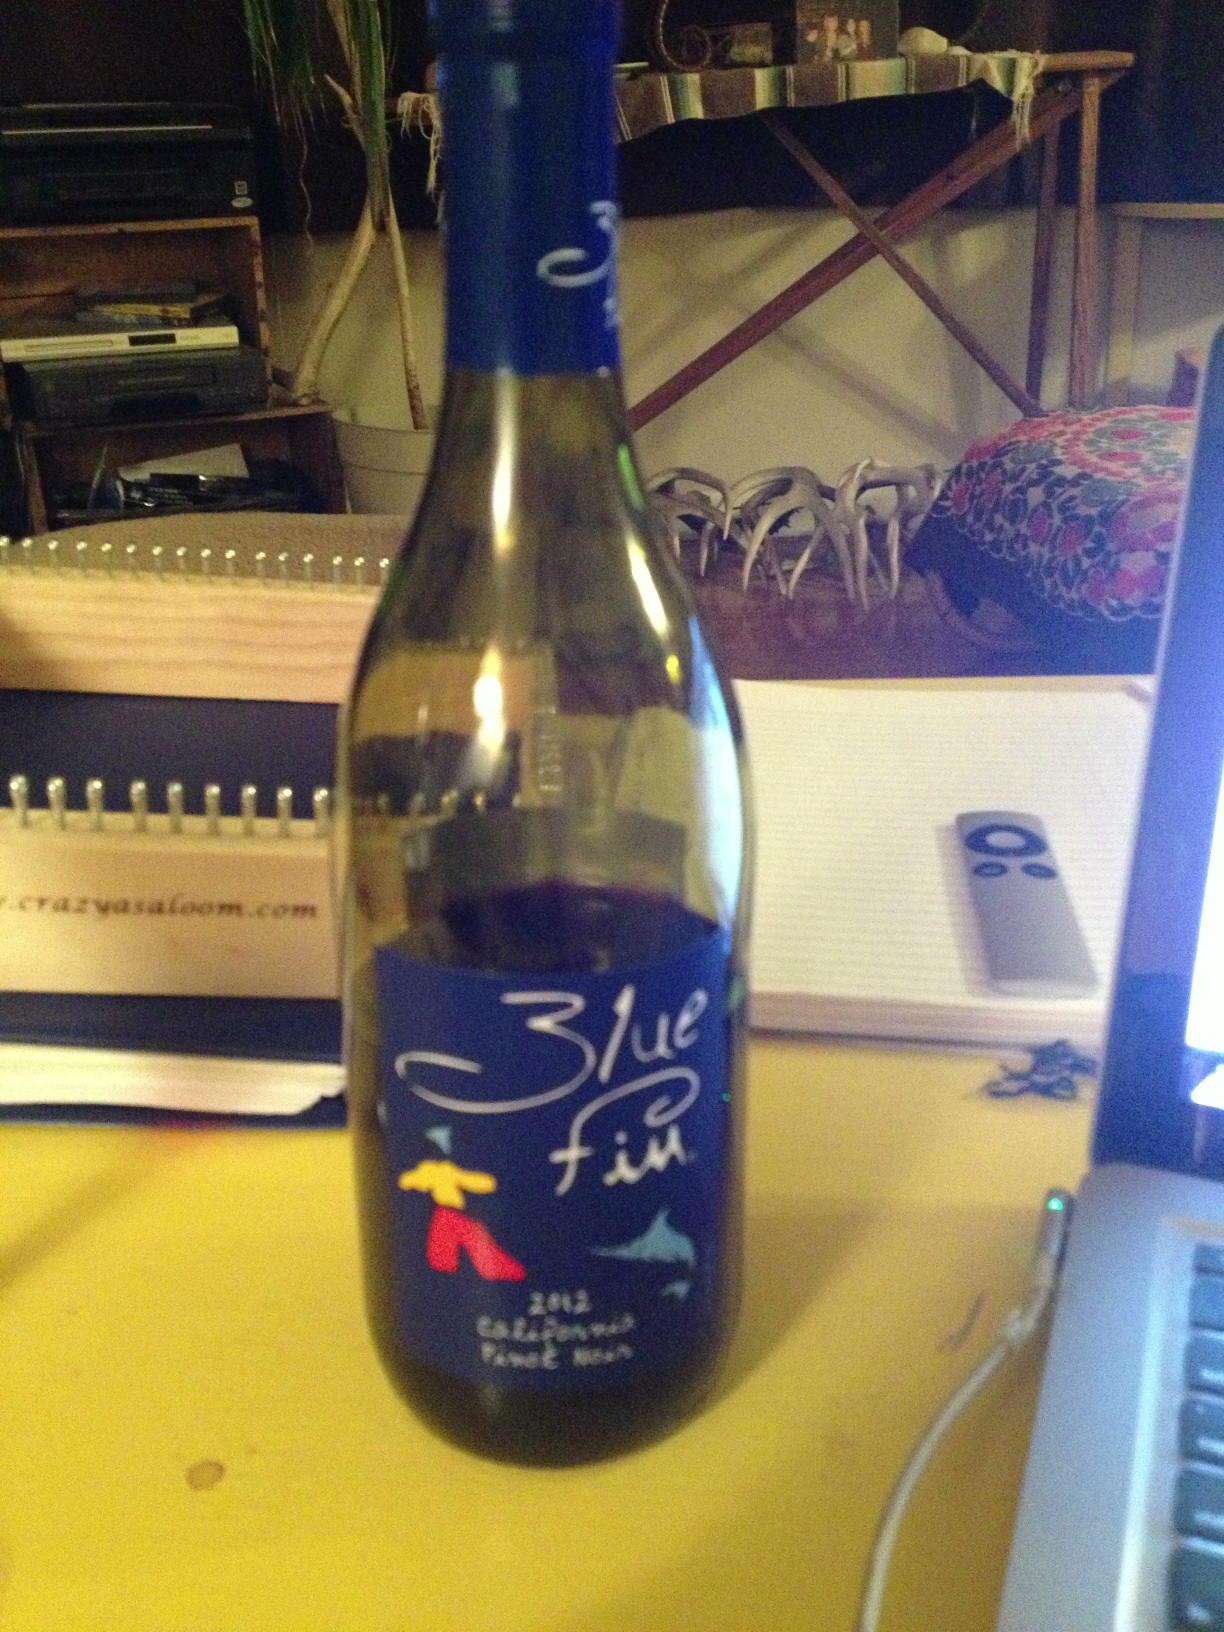What does this say? The label on the bottle reads 'Blue Fin' with additional graphics of a fish and a stylized design of a person. The wine is described as a 2012 California Pinot Noir. 